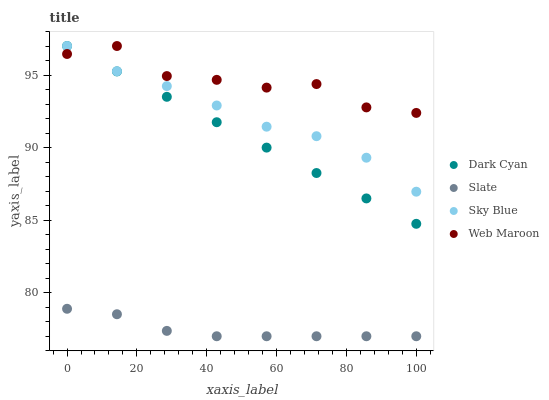Does Slate have the minimum area under the curve?
Answer yes or no. Yes. Does Web Maroon have the maximum area under the curve?
Answer yes or no. Yes. Does Sky Blue have the minimum area under the curve?
Answer yes or no. No. Does Sky Blue have the maximum area under the curve?
Answer yes or no. No. Is Dark Cyan the smoothest?
Answer yes or no. Yes. Is Web Maroon the roughest?
Answer yes or no. Yes. Is Sky Blue the smoothest?
Answer yes or no. No. Is Sky Blue the roughest?
Answer yes or no. No. Does Slate have the lowest value?
Answer yes or no. Yes. Does Sky Blue have the lowest value?
Answer yes or no. No. Does Web Maroon have the highest value?
Answer yes or no. Yes. Does Slate have the highest value?
Answer yes or no. No. Is Slate less than Sky Blue?
Answer yes or no. Yes. Is Web Maroon greater than Slate?
Answer yes or no. Yes. Does Web Maroon intersect Sky Blue?
Answer yes or no. Yes. Is Web Maroon less than Sky Blue?
Answer yes or no. No. Is Web Maroon greater than Sky Blue?
Answer yes or no. No. Does Slate intersect Sky Blue?
Answer yes or no. No. 